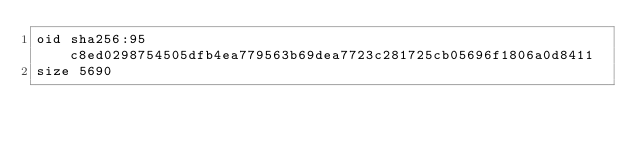Convert code to text. <code><loc_0><loc_0><loc_500><loc_500><_SQL_>oid sha256:95c8ed0298754505dfb4ea779563b69dea7723c281725cb05696f1806a0d8411
size 5690
</code> 